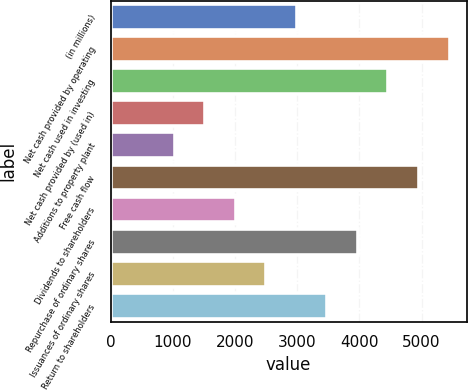<chart> <loc_0><loc_0><loc_500><loc_500><bar_chart><fcel>(in millions)<fcel>Net cash provided by operating<fcel>Net cash used in investing<fcel>Net cash provided by (used in)<fcel>Additions to property plant<fcel>Free cash flow<fcel>Dividends to shareholders<fcel>Repurchase of ordinary shares<fcel>Issuances of ordinary shares<fcel>Return to shareholders<nl><fcel>2994.6<fcel>5450.1<fcel>4467.9<fcel>1521.3<fcel>1030.2<fcel>4959<fcel>2012.4<fcel>3976.8<fcel>2503.5<fcel>3485.7<nl></chart> 